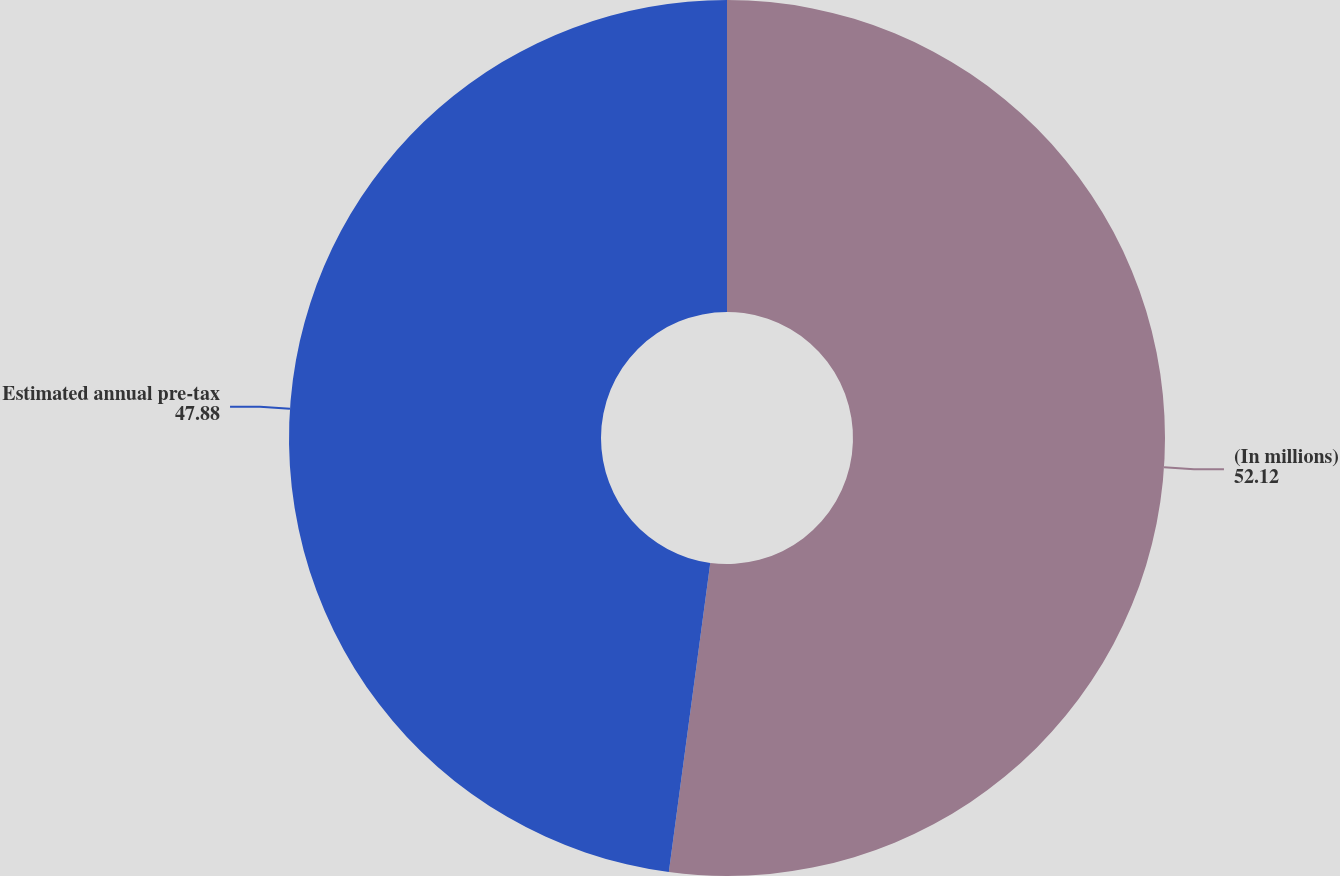Convert chart. <chart><loc_0><loc_0><loc_500><loc_500><pie_chart><fcel>(In millions)<fcel>Estimated annual pre-tax<nl><fcel>52.12%<fcel>47.88%<nl></chart> 